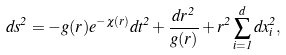<formula> <loc_0><loc_0><loc_500><loc_500>d s ^ { 2 } = - g ( r ) e ^ { - \chi ( r ) } d t ^ { 2 } + \frac { d r ^ { 2 } } { g ( r ) } + r ^ { 2 } \sum _ { i = 1 } ^ { d } d x _ { i } ^ { 2 } ,</formula> 